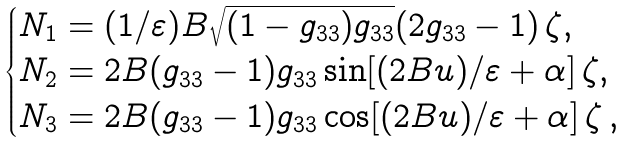Convert formula to latex. <formula><loc_0><loc_0><loc_500><loc_500>\begin{cases} N _ { 1 } = ( 1 / \varepsilon ) B \sqrt { ( 1 - g _ { 3 3 } ) g _ { 3 3 } } ( 2 g _ { 3 3 } - 1 ) \, \zeta , \\ N _ { 2 } = 2 B ( g _ { 3 3 } - 1 ) g _ { 3 3 } \sin [ ( 2 B u ) / \varepsilon + \alpha ] \, \zeta , \\ N _ { 3 } = 2 B ( g _ { 3 3 } - 1 ) g _ { 3 3 } \cos [ ( 2 B u ) / \varepsilon + \alpha ] \, \zeta \, , \end{cases}</formula> 